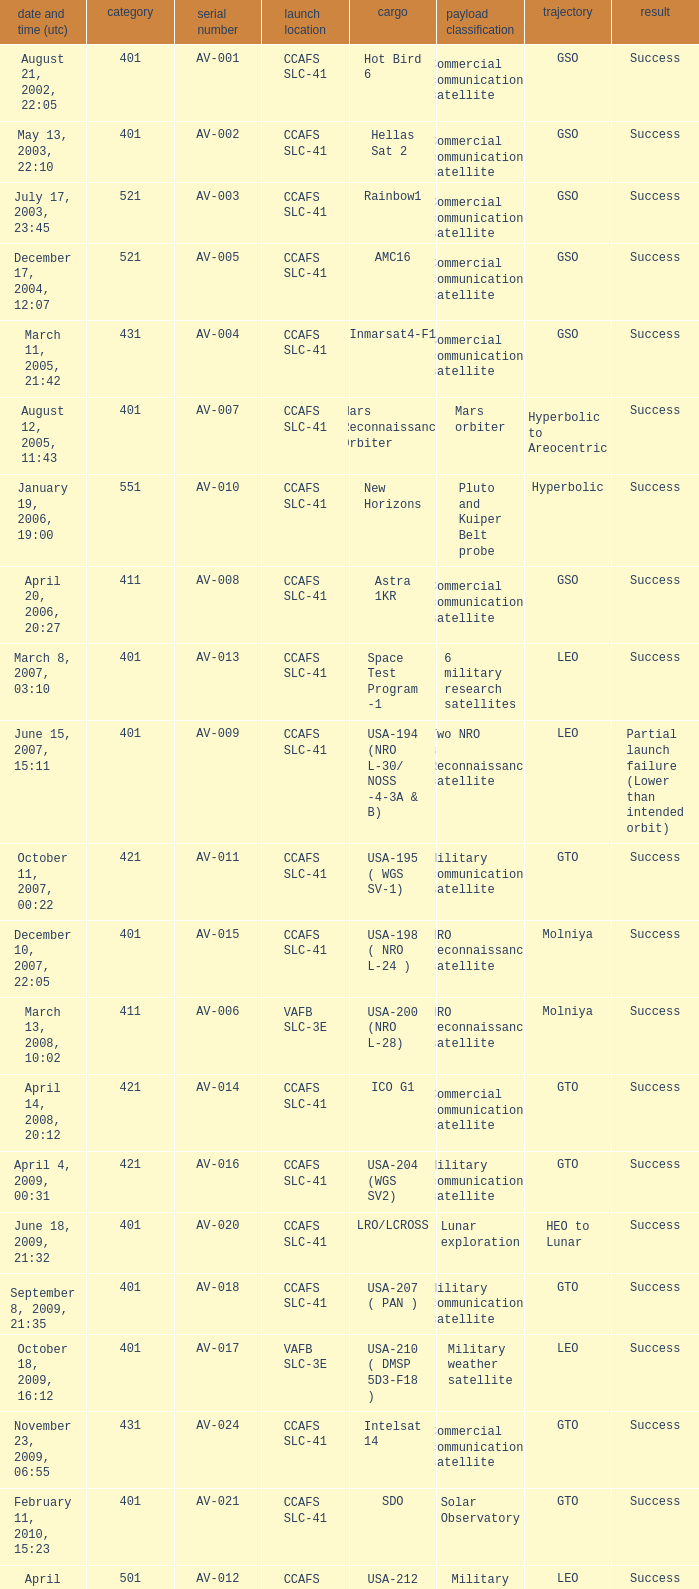When was the payload of Commercial Communications Satellite amc16? December 17, 2004, 12:07. 